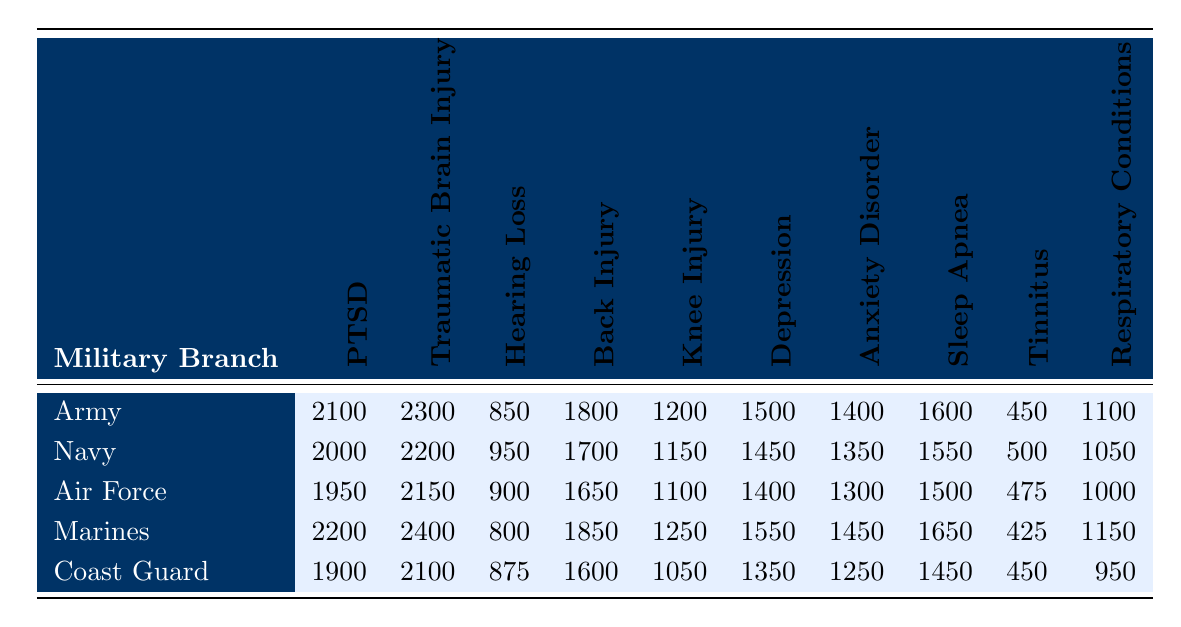What is the disability compensation rate for PTSD in the Marines? The table shows that the PTSD compensation rate for the Marines is 2200.
Answer: 2200 Which military branch has the lowest compensation rate for Hearing Loss? By comparing the Hearing Loss values, the Marines have the lowest rate at 800.
Answer: Marines What is the combined compensation rate for Back Injury in the Army and Navy? The Back Injury rates are 1800 (Army) and 1700 (Navy). The combined rate is 1800 + 1700 = 3500.
Answer: 3500 Is the compensation rate for Traumatic Brain Injury in the Air Force higher than that in the Coast Guard? The Traumatic Brain Injury rate in the Air Force is 2150, and in the Coast Guard, it is 2100. Since 2150 > 2100, the statement is true.
Answer: Yes Calculate the average compensation rate for Knee Injury across all branches. The rates for Knee Injury are: Army 1200, Navy 1150, Air Force 1100, Marines 1250, and Coast Guard 1050. Their sum is 1200 + 1150 + 1100 + 1250 + 1050 = 5800. The average is 5800 / 5 = 1160.
Answer: 1160 Which condition has the highest compensation rate in the Navy? Reviewing the Navy's compensation rates, the highest is for Traumatic Brain Injury at 2200.
Answer: Traumatic Brain Injury Are the compensation rates for Tinnitus in the Army and Air Force equal? The Tinnitus rates are 450 for the Army and 475 for the Air Force. Since 450 is not equal to 475, the statement is false.
Answer: No What is the difference in compensation rates for Anxiety Disorder between the Army and the Marines? The Anxiety Disorder rate for the Army is 1400, and for the Marines, it is 1450. The difference is 1450 - 1400 = 50.
Answer: 50 In which military branch do veterans receive the highest compensation for Depression? The Depression rate is highest in the Marines at 1550 compared to other branches.
Answer: Marines What is the total compensation rate for all conditions in the Coast Guard? Summing all compensation rates for the Coast Guard gives: 1900 + 2100 + 875 + 1600 + 1050 + 1350 + 1250 + 1450 + 450 + 950 = 11875.
Answer: 11875 